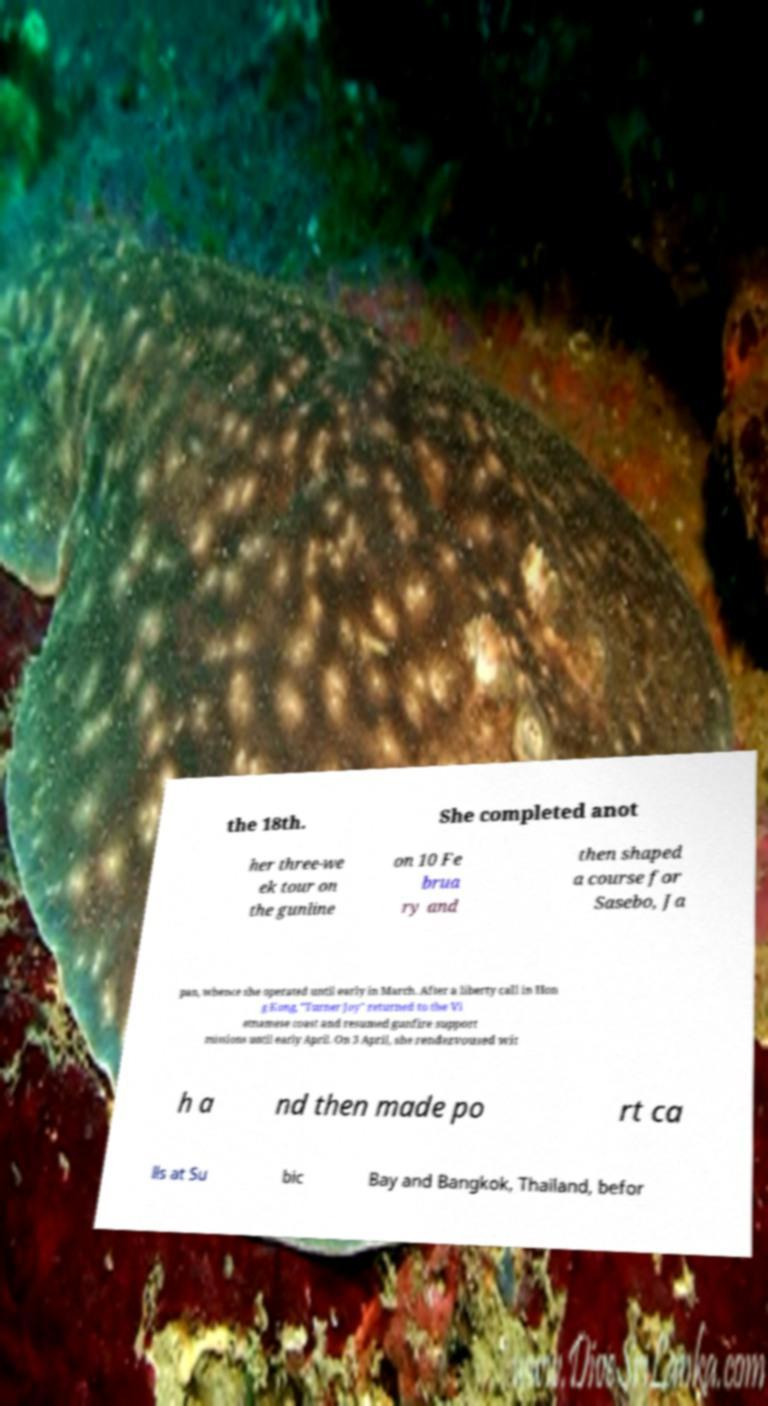I need the written content from this picture converted into text. Can you do that? the 18th. She completed anot her three-we ek tour on the gunline on 10 Fe brua ry and then shaped a course for Sasebo, Ja pan, whence she operated until early in March. After a liberty call in Hon g Kong, "Turner Joy" returned to the Vi etnamese coast and resumed gunfire support missions until early April. On 3 April, she rendezvoused wit h a nd then made po rt ca lls at Su bic Bay and Bangkok, Thailand, befor 